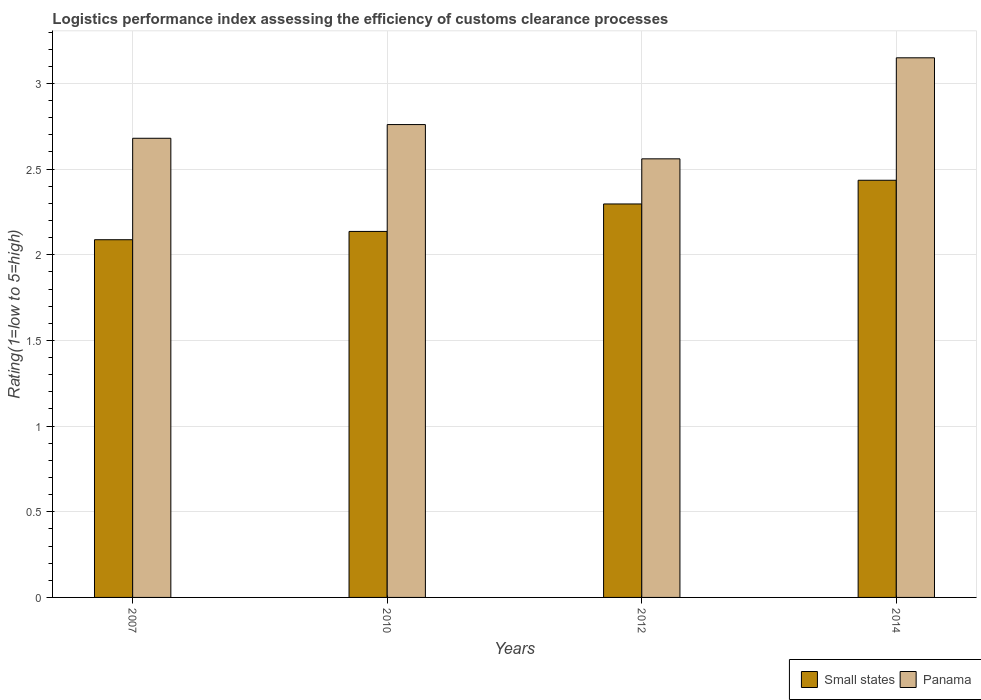Are the number of bars per tick equal to the number of legend labels?
Ensure brevity in your answer.  Yes. What is the Logistic performance index in Panama in 2010?
Offer a very short reply. 2.76. Across all years, what is the maximum Logistic performance index in Small states?
Provide a short and direct response. 2.43. Across all years, what is the minimum Logistic performance index in Panama?
Offer a very short reply. 2.56. What is the total Logistic performance index in Panama in the graph?
Provide a succinct answer. 11.15. What is the difference between the Logistic performance index in Small states in 2007 and that in 2014?
Make the answer very short. -0.35. What is the difference between the Logistic performance index in Panama in 2014 and the Logistic performance index in Small states in 2012?
Offer a very short reply. 0.85. What is the average Logistic performance index in Small states per year?
Offer a very short reply. 2.24. In the year 2007, what is the difference between the Logistic performance index in Panama and Logistic performance index in Small states?
Provide a succinct answer. 0.59. In how many years, is the Logistic performance index in Small states greater than 2.8?
Your answer should be very brief. 0. What is the ratio of the Logistic performance index in Panama in 2010 to that in 2014?
Your answer should be very brief. 0.88. What is the difference between the highest and the second highest Logistic performance index in Small states?
Make the answer very short. 0.14. What is the difference between the highest and the lowest Logistic performance index in Panama?
Your answer should be compact. 0.59. In how many years, is the Logistic performance index in Panama greater than the average Logistic performance index in Panama taken over all years?
Provide a short and direct response. 1. Is the sum of the Logistic performance index in Panama in 2012 and 2014 greater than the maximum Logistic performance index in Small states across all years?
Provide a succinct answer. Yes. What does the 1st bar from the left in 2007 represents?
Keep it short and to the point. Small states. What does the 2nd bar from the right in 2007 represents?
Ensure brevity in your answer.  Small states. Are all the bars in the graph horizontal?
Provide a short and direct response. No. Does the graph contain any zero values?
Ensure brevity in your answer.  No. Does the graph contain grids?
Offer a very short reply. Yes. What is the title of the graph?
Make the answer very short. Logistics performance index assessing the efficiency of customs clearance processes. What is the label or title of the X-axis?
Ensure brevity in your answer.  Years. What is the label or title of the Y-axis?
Your answer should be compact. Rating(1=low to 5=high). What is the Rating(1=low to 5=high) in Small states in 2007?
Provide a short and direct response. 2.09. What is the Rating(1=low to 5=high) of Panama in 2007?
Offer a very short reply. 2.68. What is the Rating(1=low to 5=high) of Small states in 2010?
Provide a short and direct response. 2.14. What is the Rating(1=low to 5=high) in Panama in 2010?
Keep it short and to the point. 2.76. What is the Rating(1=low to 5=high) of Small states in 2012?
Offer a terse response. 2.3. What is the Rating(1=low to 5=high) of Panama in 2012?
Your answer should be very brief. 2.56. What is the Rating(1=low to 5=high) in Small states in 2014?
Offer a very short reply. 2.43. What is the Rating(1=low to 5=high) of Panama in 2014?
Offer a very short reply. 3.15. Across all years, what is the maximum Rating(1=low to 5=high) in Small states?
Your response must be concise. 2.43. Across all years, what is the maximum Rating(1=low to 5=high) in Panama?
Provide a short and direct response. 3.15. Across all years, what is the minimum Rating(1=low to 5=high) in Small states?
Ensure brevity in your answer.  2.09. Across all years, what is the minimum Rating(1=low to 5=high) in Panama?
Your answer should be very brief. 2.56. What is the total Rating(1=low to 5=high) of Small states in the graph?
Your answer should be very brief. 8.96. What is the total Rating(1=low to 5=high) in Panama in the graph?
Offer a very short reply. 11.15. What is the difference between the Rating(1=low to 5=high) in Small states in 2007 and that in 2010?
Offer a terse response. -0.05. What is the difference between the Rating(1=low to 5=high) in Panama in 2007 and that in 2010?
Provide a short and direct response. -0.08. What is the difference between the Rating(1=low to 5=high) of Small states in 2007 and that in 2012?
Ensure brevity in your answer.  -0.21. What is the difference between the Rating(1=low to 5=high) in Panama in 2007 and that in 2012?
Ensure brevity in your answer.  0.12. What is the difference between the Rating(1=low to 5=high) of Small states in 2007 and that in 2014?
Your answer should be very brief. -0.35. What is the difference between the Rating(1=low to 5=high) of Panama in 2007 and that in 2014?
Make the answer very short. -0.47. What is the difference between the Rating(1=low to 5=high) of Small states in 2010 and that in 2012?
Provide a succinct answer. -0.16. What is the difference between the Rating(1=low to 5=high) of Small states in 2010 and that in 2014?
Keep it short and to the point. -0.3. What is the difference between the Rating(1=low to 5=high) in Panama in 2010 and that in 2014?
Ensure brevity in your answer.  -0.39. What is the difference between the Rating(1=low to 5=high) of Small states in 2012 and that in 2014?
Make the answer very short. -0.14. What is the difference between the Rating(1=low to 5=high) in Panama in 2012 and that in 2014?
Give a very brief answer. -0.59. What is the difference between the Rating(1=low to 5=high) in Small states in 2007 and the Rating(1=low to 5=high) in Panama in 2010?
Offer a very short reply. -0.67. What is the difference between the Rating(1=low to 5=high) in Small states in 2007 and the Rating(1=low to 5=high) in Panama in 2012?
Give a very brief answer. -0.47. What is the difference between the Rating(1=low to 5=high) of Small states in 2007 and the Rating(1=low to 5=high) of Panama in 2014?
Your answer should be compact. -1.06. What is the difference between the Rating(1=low to 5=high) of Small states in 2010 and the Rating(1=low to 5=high) of Panama in 2012?
Ensure brevity in your answer.  -0.42. What is the difference between the Rating(1=low to 5=high) in Small states in 2010 and the Rating(1=low to 5=high) in Panama in 2014?
Make the answer very short. -1.01. What is the difference between the Rating(1=low to 5=high) in Small states in 2012 and the Rating(1=low to 5=high) in Panama in 2014?
Your response must be concise. -0.85. What is the average Rating(1=low to 5=high) of Small states per year?
Keep it short and to the point. 2.24. What is the average Rating(1=low to 5=high) in Panama per year?
Your response must be concise. 2.79. In the year 2007, what is the difference between the Rating(1=low to 5=high) of Small states and Rating(1=low to 5=high) of Panama?
Make the answer very short. -0.59. In the year 2010, what is the difference between the Rating(1=low to 5=high) in Small states and Rating(1=low to 5=high) in Panama?
Your answer should be compact. -0.62. In the year 2012, what is the difference between the Rating(1=low to 5=high) of Small states and Rating(1=low to 5=high) of Panama?
Your answer should be very brief. -0.26. In the year 2014, what is the difference between the Rating(1=low to 5=high) in Small states and Rating(1=low to 5=high) in Panama?
Your answer should be very brief. -0.71. What is the ratio of the Rating(1=low to 5=high) in Small states in 2007 to that in 2010?
Provide a succinct answer. 0.98. What is the ratio of the Rating(1=low to 5=high) of Small states in 2007 to that in 2012?
Provide a succinct answer. 0.91. What is the ratio of the Rating(1=low to 5=high) in Panama in 2007 to that in 2012?
Keep it short and to the point. 1.05. What is the ratio of the Rating(1=low to 5=high) of Small states in 2007 to that in 2014?
Keep it short and to the point. 0.86. What is the ratio of the Rating(1=low to 5=high) in Panama in 2007 to that in 2014?
Your answer should be compact. 0.85. What is the ratio of the Rating(1=low to 5=high) in Small states in 2010 to that in 2012?
Provide a succinct answer. 0.93. What is the ratio of the Rating(1=low to 5=high) in Panama in 2010 to that in 2012?
Make the answer very short. 1.08. What is the ratio of the Rating(1=low to 5=high) in Small states in 2010 to that in 2014?
Ensure brevity in your answer.  0.88. What is the ratio of the Rating(1=low to 5=high) in Panama in 2010 to that in 2014?
Provide a succinct answer. 0.88. What is the ratio of the Rating(1=low to 5=high) in Small states in 2012 to that in 2014?
Give a very brief answer. 0.94. What is the ratio of the Rating(1=low to 5=high) in Panama in 2012 to that in 2014?
Provide a succinct answer. 0.81. What is the difference between the highest and the second highest Rating(1=low to 5=high) of Small states?
Provide a short and direct response. 0.14. What is the difference between the highest and the second highest Rating(1=low to 5=high) of Panama?
Ensure brevity in your answer.  0.39. What is the difference between the highest and the lowest Rating(1=low to 5=high) of Small states?
Give a very brief answer. 0.35. What is the difference between the highest and the lowest Rating(1=low to 5=high) of Panama?
Provide a short and direct response. 0.59. 